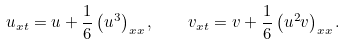Convert formula to latex. <formula><loc_0><loc_0><loc_500><loc_500>u _ { x t } = u + \frac { 1 } { 6 } \left ( u ^ { 3 } \right ) _ { x x } , \quad v _ { x t } = v + \frac { 1 } { 6 } \left ( u ^ { 2 } v \right ) _ { x x } .</formula> 